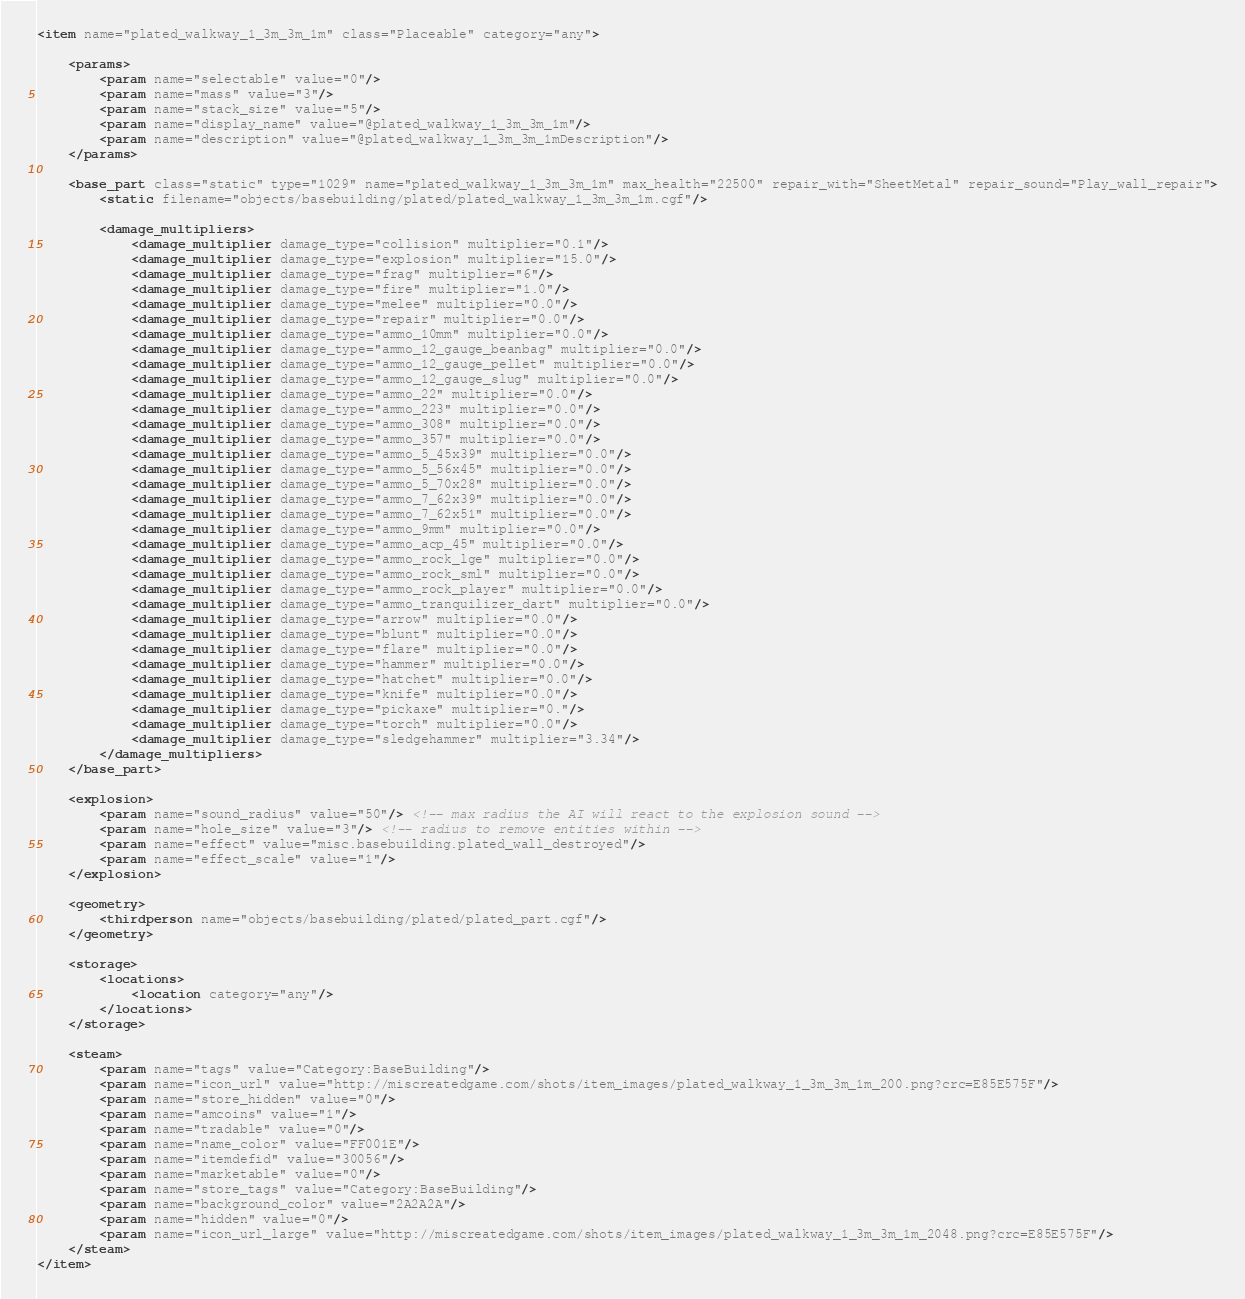Convert code to text. <code><loc_0><loc_0><loc_500><loc_500><_XML_><item name="plated_walkway_1_3m_3m_1m" class="Placeable" category="any">

	<params>
		<param name="selectable" value="0"/>
		<param name="mass" value="3"/>
		<param name="stack_size" value="5"/>
		<param name="display_name" value="@plated_walkway_1_3m_3m_1m"/>
		<param name="description" value="@plated_walkway_1_3m_3m_1mDescription"/>
	</params>

	<base_part class="static" type="1029" name="plated_walkway_1_3m_3m_1m" max_health="22500" repair_with="SheetMetal" repair_sound="Play_wall_repair">
		<static filename="objects/basebuilding/plated/plated_walkway_1_3m_3m_1m.cgf"/>

		<damage_multipliers>
			<damage_multiplier damage_type="collision" multiplier="0.1"/>
			<damage_multiplier damage_type="explosion" multiplier="15.0"/>
			<damage_multiplier damage_type="frag" multiplier="6"/>
			<damage_multiplier damage_type="fire" multiplier="1.0"/>
			<damage_multiplier damage_type="melee" multiplier="0.0"/>
			<damage_multiplier damage_type="repair" multiplier="0.0"/>
			<damage_multiplier damage_type="ammo_10mm" multiplier="0.0"/>
			<damage_multiplier damage_type="ammo_12_gauge_beanbag" multiplier="0.0"/>
			<damage_multiplier damage_type="ammo_12_gauge_pellet" multiplier="0.0"/>
			<damage_multiplier damage_type="ammo_12_gauge_slug" multiplier="0.0"/>
			<damage_multiplier damage_type="ammo_22" multiplier="0.0"/>
			<damage_multiplier damage_type="ammo_223" multiplier="0.0"/>
			<damage_multiplier damage_type="ammo_308" multiplier="0.0"/>
			<damage_multiplier damage_type="ammo_357" multiplier="0.0"/>
			<damage_multiplier damage_type="ammo_5_45x39" multiplier="0.0"/>
			<damage_multiplier damage_type="ammo_5_56x45" multiplier="0.0"/>
			<damage_multiplier damage_type="ammo_5_70x28" multiplier="0.0"/>
			<damage_multiplier damage_type="ammo_7_62x39" multiplier="0.0"/>
			<damage_multiplier damage_type="ammo_7_62x51" multiplier="0.0"/>
			<damage_multiplier damage_type="ammo_9mm" multiplier="0.0"/>
			<damage_multiplier damage_type="ammo_acp_45" multiplier="0.0"/>
			<damage_multiplier damage_type="ammo_rock_lge" multiplier="0.0"/>
			<damage_multiplier damage_type="ammo_rock_sml" multiplier="0.0"/>
			<damage_multiplier damage_type="ammo_rock_player" multiplier="0.0"/>
			<damage_multiplier damage_type="ammo_tranquilizer_dart" multiplier="0.0"/>
			<damage_multiplier damage_type="arrow" multiplier="0.0"/>
			<damage_multiplier damage_type="blunt" multiplier="0.0"/>
			<damage_multiplier damage_type="flare" multiplier="0.0"/>
			<damage_multiplier damage_type="hammer" multiplier="0.0"/>
			<damage_multiplier damage_type="hatchet" multiplier="0.0"/>
			<damage_multiplier damage_type="knife" multiplier="0.0"/>
			<damage_multiplier damage_type="pickaxe" multiplier="0."/>
			<damage_multiplier damage_type="torch" multiplier="0.0"/>
			<damage_multiplier damage_type="sledgehammer" multiplier="3.34"/>
		</damage_multipliers>
	</base_part>
	
	<explosion>
		<param name="sound_radius" value="50"/> <!-- max radius the AI will react to the explosion sound -->
		<param name="hole_size" value="3"/> <!-- radius to remove entities within -->
		<param name="effect" value="misc.basebuilding.plated_wall_destroyed"/>
		<param name="effect_scale" value="1"/>
	</explosion>

	<geometry>
		<thirdperson name="objects/basebuilding/plated/plated_part.cgf"/>
	</geometry>

	<storage>
		<locations>
			<location category="any"/>
		</locations>
	</storage>

	<steam>
		<param name="tags" value="Category:BaseBuilding"/>
		<param name="icon_url" value="http://miscreatedgame.com/shots/item_images/plated_walkway_1_3m_3m_1m_200.png?crc=E85E575F"/>
		<param name="store_hidden" value="0"/>
		<param name="amcoins" value="1"/>
		<param name="tradable" value="0"/>
		<param name="name_color" value="FF001E"/>
		<param name="itemdefid" value="30056"/>
		<param name="marketable" value="0"/>
		<param name="store_tags" value="Category:BaseBuilding"/>
		<param name="background_color" value="2A2A2A"/>
		<param name="hidden" value="0"/>
		<param name="icon_url_large" value="http://miscreatedgame.com/shots/item_images/plated_walkway_1_3m_3m_1m_2048.png?crc=E85E575F"/>
	</steam>
</item></code> 